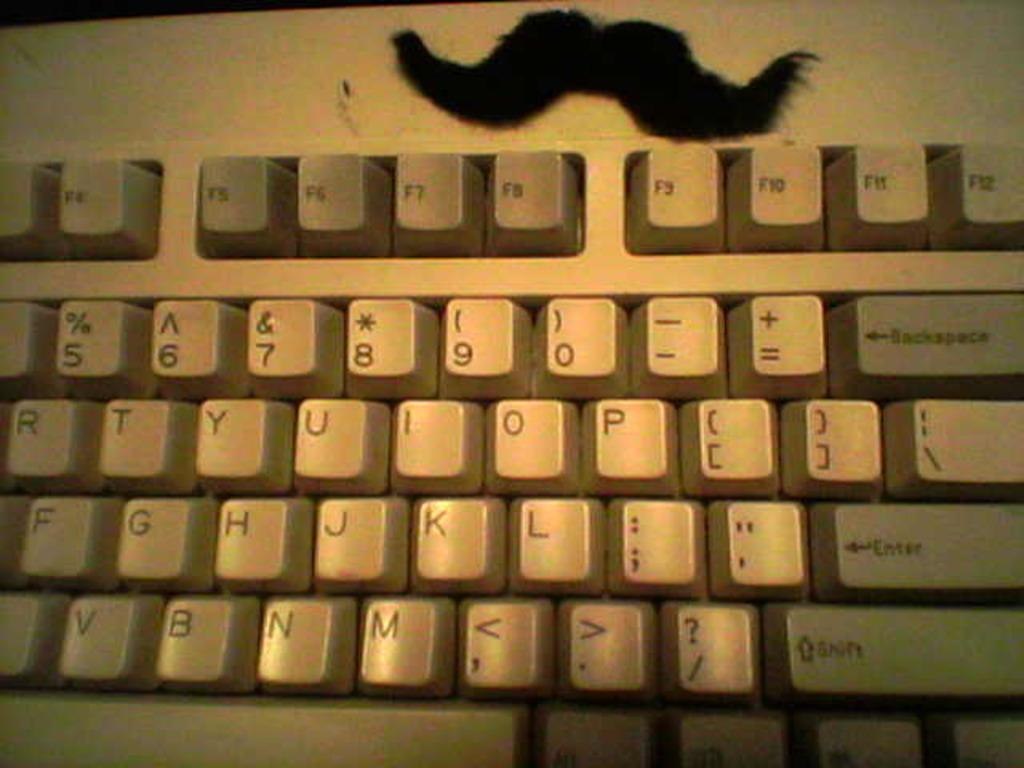<image>
Describe the image concisely. Part of a beige keyboard whose "return" key says "Enter." 